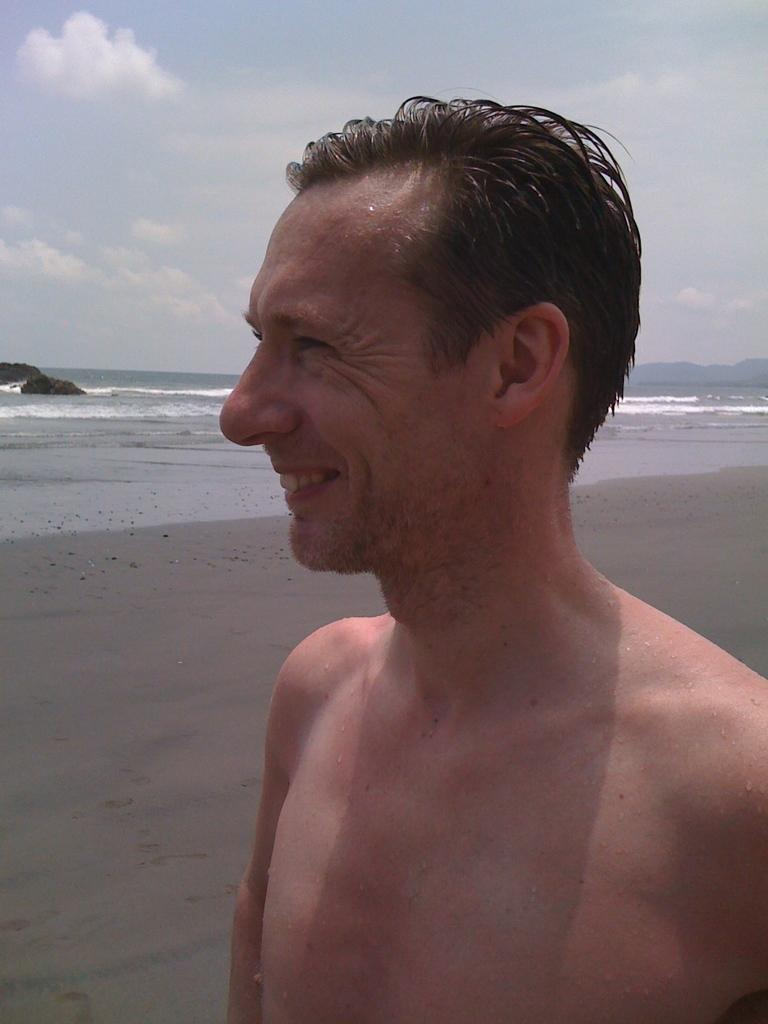What is the main subject of the image? There is a man standing in the image. Where is the man standing? The man is standing on the seashore. What can be seen in the background of the image? The sea, rocks, and sky are visible in the image. What is the condition of the sky in the image? Clouds are present in the sky. What type of nest can be seen in the image? There is no nest present in the image; it features a man standing on the seashore with the sea, rocks, and sky visible in the background. 